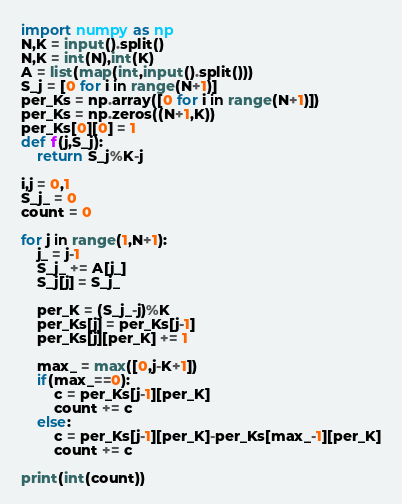Convert code to text. <code><loc_0><loc_0><loc_500><loc_500><_Python_>import numpy as np
N,K = input().split()
N,K = int(N),int(K)
A = list(map(int,input().split()))
S_j = [0 for i in range(N+1)]
per_Ks = np.array([0 for i in range(N+1)])
per_Ks = np.zeros((N+1,K))
per_Ks[0][0] = 1
def f(j,S_j):
    return S_j%K-j 

i,j = 0,1
S_j_ = 0
count = 0

for j in range(1,N+1):
    j_ = j-1
    S_j_ += A[j_]
    S_j[j] = S_j_
    
    per_K = (S_j_-j)%K
    per_Ks[j] = per_Ks[j-1]
    per_Ks[j][per_K] += 1
    
    max_ = max([0,j-K+1])
    if(max_==0):
        c = per_Ks[j-1][per_K]
        count += c
    else:
        c = per_Ks[j-1][per_K]-per_Ks[max_-1][per_K]
        count += c
        
print(int(count))
</code> 